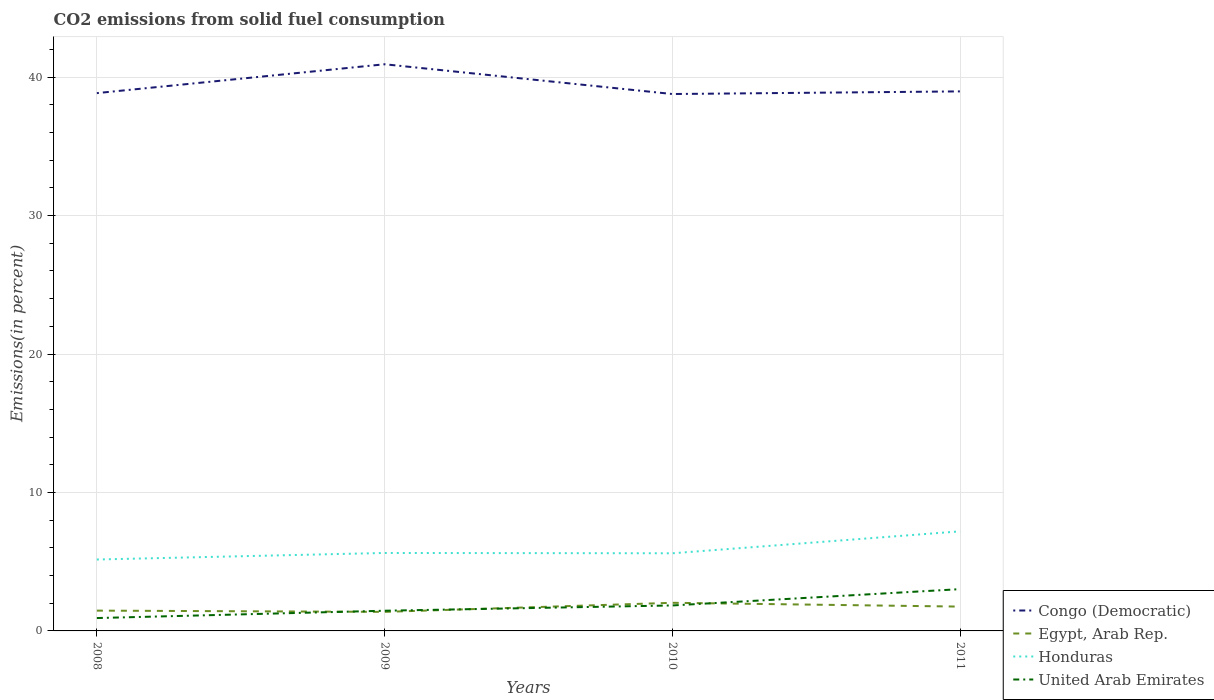How many different coloured lines are there?
Your response must be concise. 4. Does the line corresponding to United Arab Emirates intersect with the line corresponding to Honduras?
Provide a succinct answer. No. Is the number of lines equal to the number of legend labels?
Offer a very short reply. Yes. Across all years, what is the maximum total CO2 emitted in United Arab Emirates?
Ensure brevity in your answer.  0.93. What is the total total CO2 emitted in Egypt, Arab Rep. in the graph?
Provide a short and direct response. -0.66. What is the difference between the highest and the second highest total CO2 emitted in Honduras?
Offer a very short reply. 2.03. Is the total CO2 emitted in United Arab Emirates strictly greater than the total CO2 emitted in Honduras over the years?
Provide a short and direct response. Yes. How many lines are there?
Give a very brief answer. 4. How many years are there in the graph?
Your answer should be very brief. 4. What is the difference between two consecutive major ticks on the Y-axis?
Your answer should be compact. 10. Does the graph contain any zero values?
Your answer should be compact. No. Does the graph contain grids?
Give a very brief answer. Yes. Where does the legend appear in the graph?
Make the answer very short. Bottom right. How many legend labels are there?
Make the answer very short. 4. How are the legend labels stacked?
Provide a succinct answer. Vertical. What is the title of the graph?
Offer a terse response. CO2 emissions from solid fuel consumption. What is the label or title of the X-axis?
Offer a very short reply. Years. What is the label or title of the Y-axis?
Your response must be concise. Emissions(in percent). What is the Emissions(in percent) of Congo (Democratic) in 2008?
Give a very brief answer. 38.85. What is the Emissions(in percent) of Egypt, Arab Rep. in 2008?
Give a very brief answer. 1.47. What is the Emissions(in percent) of Honduras in 2008?
Ensure brevity in your answer.  5.16. What is the Emissions(in percent) of United Arab Emirates in 2008?
Offer a very short reply. 0.93. What is the Emissions(in percent) of Congo (Democratic) in 2009?
Offer a terse response. 40.93. What is the Emissions(in percent) of Egypt, Arab Rep. in 2009?
Keep it short and to the point. 1.38. What is the Emissions(in percent) of Honduras in 2009?
Your answer should be compact. 5.63. What is the Emissions(in percent) of United Arab Emirates in 2009?
Keep it short and to the point. 1.46. What is the Emissions(in percent) in Congo (Democratic) in 2010?
Offer a very short reply. 38.78. What is the Emissions(in percent) of Egypt, Arab Rep. in 2010?
Your response must be concise. 2.03. What is the Emissions(in percent) in Honduras in 2010?
Your answer should be compact. 5.61. What is the Emissions(in percent) of United Arab Emirates in 2010?
Give a very brief answer. 1.84. What is the Emissions(in percent) in Congo (Democratic) in 2011?
Make the answer very short. 38.97. What is the Emissions(in percent) of Egypt, Arab Rep. in 2011?
Provide a short and direct response. 1.76. What is the Emissions(in percent) in Honduras in 2011?
Offer a very short reply. 7.19. What is the Emissions(in percent) of United Arab Emirates in 2011?
Offer a terse response. 3.02. Across all years, what is the maximum Emissions(in percent) in Congo (Democratic)?
Make the answer very short. 40.93. Across all years, what is the maximum Emissions(in percent) of Egypt, Arab Rep.?
Make the answer very short. 2.03. Across all years, what is the maximum Emissions(in percent) of Honduras?
Provide a short and direct response. 7.19. Across all years, what is the maximum Emissions(in percent) in United Arab Emirates?
Offer a terse response. 3.02. Across all years, what is the minimum Emissions(in percent) in Congo (Democratic)?
Your answer should be very brief. 38.78. Across all years, what is the minimum Emissions(in percent) in Egypt, Arab Rep.?
Your response must be concise. 1.38. Across all years, what is the minimum Emissions(in percent) of Honduras?
Your response must be concise. 5.16. Across all years, what is the minimum Emissions(in percent) in United Arab Emirates?
Give a very brief answer. 0.93. What is the total Emissions(in percent) in Congo (Democratic) in the graph?
Offer a very short reply. 157.53. What is the total Emissions(in percent) of Egypt, Arab Rep. in the graph?
Make the answer very short. 6.63. What is the total Emissions(in percent) of Honduras in the graph?
Your answer should be compact. 23.59. What is the total Emissions(in percent) in United Arab Emirates in the graph?
Offer a terse response. 7.25. What is the difference between the Emissions(in percent) of Congo (Democratic) in 2008 and that in 2009?
Provide a short and direct response. -2.08. What is the difference between the Emissions(in percent) of Egypt, Arab Rep. in 2008 and that in 2009?
Your response must be concise. 0.09. What is the difference between the Emissions(in percent) of Honduras in 2008 and that in 2009?
Make the answer very short. -0.47. What is the difference between the Emissions(in percent) of United Arab Emirates in 2008 and that in 2009?
Provide a short and direct response. -0.53. What is the difference between the Emissions(in percent) of Congo (Democratic) in 2008 and that in 2010?
Your response must be concise. 0.07. What is the difference between the Emissions(in percent) in Egypt, Arab Rep. in 2008 and that in 2010?
Make the answer very short. -0.57. What is the difference between the Emissions(in percent) in Honduras in 2008 and that in 2010?
Provide a succinct answer. -0.45. What is the difference between the Emissions(in percent) of United Arab Emirates in 2008 and that in 2010?
Offer a terse response. -0.91. What is the difference between the Emissions(in percent) of Congo (Democratic) in 2008 and that in 2011?
Make the answer very short. -0.12. What is the difference between the Emissions(in percent) in Egypt, Arab Rep. in 2008 and that in 2011?
Make the answer very short. -0.29. What is the difference between the Emissions(in percent) of Honduras in 2008 and that in 2011?
Your response must be concise. -2.03. What is the difference between the Emissions(in percent) of United Arab Emirates in 2008 and that in 2011?
Make the answer very short. -2.09. What is the difference between the Emissions(in percent) in Congo (Democratic) in 2009 and that in 2010?
Offer a very short reply. 2.15. What is the difference between the Emissions(in percent) in Egypt, Arab Rep. in 2009 and that in 2010?
Offer a very short reply. -0.66. What is the difference between the Emissions(in percent) in Honduras in 2009 and that in 2010?
Your answer should be very brief. 0.02. What is the difference between the Emissions(in percent) in United Arab Emirates in 2009 and that in 2010?
Offer a very short reply. -0.38. What is the difference between the Emissions(in percent) of Congo (Democratic) in 2009 and that in 2011?
Ensure brevity in your answer.  1.96. What is the difference between the Emissions(in percent) in Egypt, Arab Rep. in 2009 and that in 2011?
Offer a terse response. -0.38. What is the difference between the Emissions(in percent) in Honduras in 2009 and that in 2011?
Offer a terse response. -1.56. What is the difference between the Emissions(in percent) of United Arab Emirates in 2009 and that in 2011?
Offer a very short reply. -1.56. What is the difference between the Emissions(in percent) of Congo (Democratic) in 2010 and that in 2011?
Your answer should be very brief. -0.19. What is the difference between the Emissions(in percent) in Egypt, Arab Rep. in 2010 and that in 2011?
Provide a succinct answer. 0.27. What is the difference between the Emissions(in percent) in Honduras in 2010 and that in 2011?
Ensure brevity in your answer.  -1.58. What is the difference between the Emissions(in percent) in United Arab Emirates in 2010 and that in 2011?
Give a very brief answer. -1.18. What is the difference between the Emissions(in percent) in Congo (Democratic) in 2008 and the Emissions(in percent) in Egypt, Arab Rep. in 2009?
Ensure brevity in your answer.  37.47. What is the difference between the Emissions(in percent) in Congo (Democratic) in 2008 and the Emissions(in percent) in Honduras in 2009?
Your answer should be compact. 33.22. What is the difference between the Emissions(in percent) in Congo (Democratic) in 2008 and the Emissions(in percent) in United Arab Emirates in 2009?
Keep it short and to the point. 37.39. What is the difference between the Emissions(in percent) in Egypt, Arab Rep. in 2008 and the Emissions(in percent) in Honduras in 2009?
Your answer should be compact. -4.16. What is the difference between the Emissions(in percent) of Egypt, Arab Rep. in 2008 and the Emissions(in percent) of United Arab Emirates in 2009?
Your response must be concise. 0.01. What is the difference between the Emissions(in percent) in Honduras in 2008 and the Emissions(in percent) in United Arab Emirates in 2009?
Your answer should be compact. 3.7. What is the difference between the Emissions(in percent) of Congo (Democratic) in 2008 and the Emissions(in percent) of Egypt, Arab Rep. in 2010?
Offer a very short reply. 36.82. What is the difference between the Emissions(in percent) of Congo (Democratic) in 2008 and the Emissions(in percent) of Honduras in 2010?
Offer a terse response. 33.24. What is the difference between the Emissions(in percent) in Congo (Democratic) in 2008 and the Emissions(in percent) in United Arab Emirates in 2010?
Make the answer very short. 37.01. What is the difference between the Emissions(in percent) in Egypt, Arab Rep. in 2008 and the Emissions(in percent) in Honduras in 2010?
Make the answer very short. -4.14. What is the difference between the Emissions(in percent) in Egypt, Arab Rep. in 2008 and the Emissions(in percent) in United Arab Emirates in 2010?
Provide a succinct answer. -0.37. What is the difference between the Emissions(in percent) of Honduras in 2008 and the Emissions(in percent) of United Arab Emirates in 2010?
Your answer should be compact. 3.32. What is the difference between the Emissions(in percent) of Congo (Democratic) in 2008 and the Emissions(in percent) of Egypt, Arab Rep. in 2011?
Provide a short and direct response. 37.09. What is the difference between the Emissions(in percent) in Congo (Democratic) in 2008 and the Emissions(in percent) in Honduras in 2011?
Provide a short and direct response. 31.66. What is the difference between the Emissions(in percent) of Congo (Democratic) in 2008 and the Emissions(in percent) of United Arab Emirates in 2011?
Provide a short and direct response. 35.83. What is the difference between the Emissions(in percent) of Egypt, Arab Rep. in 2008 and the Emissions(in percent) of Honduras in 2011?
Offer a very short reply. -5.73. What is the difference between the Emissions(in percent) of Egypt, Arab Rep. in 2008 and the Emissions(in percent) of United Arab Emirates in 2011?
Your answer should be very brief. -1.55. What is the difference between the Emissions(in percent) in Honduras in 2008 and the Emissions(in percent) in United Arab Emirates in 2011?
Provide a short and direct response. 2.14. What is the difference between the Emissions(in percent) in Congo (Democratic) in 2009 and the Emissions(in percent) in Egypt, Arab Rep. in 2010?
Offer a terse response. 38.9. What is the difference between the Emissions(in percent) of Congo (Democratic) in 2009 and the Emissions(in percent) of Honduras in 2010?
Your answer should be compact. 35.32. What is the difference between the Emissions(in percent) in Congo (Democratic) in 2009 and the Emissions(in percent) in United Arab Emirates in 2010?
Offer a very short reply. 39.09. What is the difference between the Emissions(in percent) of Egypt, Arab Rep. in 2009 and the Emissions(in percent) of Honduras in 2010?
Your response must be concise. -4.23. What is the difference between the Emissions(in percent) in Egypt, Arab Rep. in 2009 and the Emissions(in percent) in United Arab Emirates in 2010?
Your answer should be compact. -0.46. What is the difference between the Emissions(in percent) in Honduras in 2009 and the Emissions(in percent) in United Arab Emirates in 2010?
Provide a short and direct response. 3.79. What is the difference between the Emissions(in percent) in Congo (Democratic) in 2009 and the Emissions(in percent) in Egypt, Arab Rep. in 2011?
Offer a terse response. 39.17. What is the difference between the Emissions(in percent) of Congo (Democratic) in 2009 and the Emissions(in percent) of Honduras in 2011?
Your answer should be very brief. 33.74. What is the difference between the Emissions(in percent) of Congo (Democratic) in 2009 and the Emissions(in percent) of United Arab Emirates in 2011?
Your response must be concise. 37.91. What is the difference between the Emissions(in percent) of Egypt, Arab Rep. in 2009 and the Emissions(in percent) of Honduras in 2011?
Your response must be concise. -5.82. What is the difference between the Emissions(in percent) of Egypt, Arab Rep. in 2009 and the Emissions(in percent) of United Arab Emirates in 2011?
Your answer should be very brief. -1.64. What is the difference between the Emissions(in percent) of Honduras in 2009 and the Emissions(in percent) of United Arab Emirates in 2011?
Ensure brevity in your answer.  2.61. What is the difference between the Emissions(in percent) of Congo (Democratic) in 2010 and the Emissions(in percent) of Egypt, Arab Rep. in 2011?
Keep it short and to the point. 37.03. What is the difference between the Emissions(in percent) in Congo (Democratic) in 2010 and the Emissions(in percent) in Honduras in 2011?
Your answer should be compact. 31.59. What is the difference between the Emissions(in percent) in Congo (Democratic) in 2010 and the Emissions(in percent) in United Arab Emirates in 2011?
Provide a succinct answer. 35.76. What is the difference between the Emissions(in percent) of Egypt, Arab Rep. in 2010 and the Emissions(in percent) of Honduras in 2011?
Make the answer very short. -5.16. What is the difference between the Emissions(in percent) in Egypt, Arab Rep. in 2010 and the Emissions(in percent) in United Arab Emirates in 2011?
Ensure brevity in your answer.  -0.99. What is the difference between the Emissions(in percent) in Honduras in 2010 and the Emissions(in percent) in United Arab Emirates in 2011?
Offer a very short reply. 2.59. What is the average Emissions(in percent) in Congo (Democratic) per year?
Offer a terse response. 39.38. What is the average Emissions(in percent) in Egypt, Arab Rep. per year?
Your answer should be very brief. 1.66. What is the average Emissions(in percent) in Honduras per year?
Make the answer very short. 5.9. What is the average Emissions(in percent) of United Arab Emirates per year?
Provide a short and direct response. 1.81. In the year 2008, what is the difference between the Emissions(in percent) of Congo (Democratic) and Emissions(in percent) of Egypt, Arab Rep.?
Keep it short and to the point. 37.38. In the year 2008, what is the difference between the Emissions(in percent) in Congo (Democratic) and Emissions(in percent) in Honduras?
Your response must be concise. 33.69. In the year 2008, what is the difference between the Emissions(in percent) of Congo (Democratic) and Emissions(in percent) of United Arab Emirates?
Keep it short and to the point. 37.92. In the year 2008, what is the difference between the Emissions(in percent) in Egypt, Arab Rep. and Emissions(in percent) in Honduras?
Your answer should be compact. -3.69. In the year 2008, what is the difference between the Emissions(in percent) of Egypt, Arab Rep. and Emissions(in percent) of United Arab Emirates?
Ensure brevity in your answer.  0.54. In the year 2008, what is the difference between the Emissions(in percent) in Honduras and Emissions(in percent) in United Arab Emirates?
Provide a succinct answer. 4.23. In the year 2009, what is the difference between the Emissions(in percent) in Congo (Democratic) and Emissions(in percent) in Egypt, Arab Rep.?
Ensure brevity in your answer.  39.56. In the year 2009, what is the difference between the Emissions(in percent) in Congo (Democratic) and Emissions(in percent) in Honduras?
Provide a succinct answer. 35.3. In the year 2009, what is the difference between the Emissions(in percent) of Congo (Democratic) and Emissions(in percent) of United Arab Emirates?
Ensure brevity in your answer.  39.47. In the year 2009, what is the difference between the Emissions(in percent) in Egypt, Arab Rep. and Emissions(in percent) in Honduras?
Offer a very short reply. -4.26. In the year 2009, what is the difference between the Emissions(in percent) in Egypt, Arab Rep. and Emissions(in percent) in United Arab Emirates?
Provide a succinct answer. -0.08. In the year 2009, what is the difference between the Emissions(in percent) of Honduras and Emissions(in percent) of United Arab Emirates?
Give a very brief answer. 4.17. In the year 2010, what is the difference between the Emissions(in percent) of Congo (Democratic) and Emissions(in percent) of Egypt, Arab Rep.?
Ensure brevity in your answer.  36.75. In the year 2010, what is the difference between the Emissions(in percent) in Congo (Democratic) and Emissions(in percent) in Honduras?
Make the answer very short. 33.17. In the year 2010, what is the difference between the Emissions(in percent) in Congo (Democratic) and Emissions(in percent) in United Arab Emirates?
Offer a terse response. 36.94. In the year 2010, what is the difference between the Emissions(in percent) in Egypt, Arab Rep. and Emissions(in percent) in Honduras?
Your answer should be very brief. -3.58. In the year 2010, what is the difference between the Emissions(in percent) of Egypt, Arab Rep. and Emissions(in percent) of United Arab Emirates?
Offer a terse response. 0.19. In the year 2010, what is the difference between the Emissions(in percent) of Honduras and Emissions(in percent) of United Arab Emirates?
Offer a terse response. 3.77. In the year 2011, what is the difference between the Emissions(in percent) in Congo (Democratic) and Emissions(in percent) in Egypt, Arab Rep.?
Your answer should be very brief. 37.22. In the year 2011, what is the difference between the Emissions(in percent) of Congo (Democratic) and Emissions(in percent) of Honduras?
Your answer should be compact. 31.78. In the year 2011, what is the difference between the Emissions(in percent) of Congo (Democratic) and Emissions(in percent) of United Arab Emirates?
Provide a succinct answer. 35.95. In the year 2011, what is the difference between the Emissions(in percent) in Egypt, Arab Rep. and Emissions(in percent) in Honduras?
Your response must be concise. -5.44. In the year 2011, what is the difference between the Emissions(in percent) in Egypt, Arab Rep. and Emissions(in percent) in United Arab Emirates?
Provide a short and direct response. -1.26. In the year 2011, what is the difference between the Emissions(in percent) in Honduras and Emissions(in percent) in United Arab Emirates?
Offer a very short reply. 4.17. What is the ratio of the Emissions(in percent) of Congo (Democratic) in 2008 to that in 2009?
Your answer should be compact. 0.95. What is the ratio of the Emissions(in percent) in Egypt, Arab Rep. in 2008 to that in 2009?
Provide a short and direct response. 1.07. What is the ratio of the Emissions(in percent) in Honduras in 2008 to that in 2009?
Your response must be concise. 0.92. What is the ratio of the Emissions(in percent) of United Arab Emirates in 2008 to that in 2009?
Provide a succinct answer. 0.64. What is the ratio of the Emissions(in percent) of Congo (Democratic) in 2008 to that in 2010?
Ensure brevity in your answer.  1. What is the ratio of the Emissions(in percent) in Egypt, Arab Rep. in 2008 to that in 2010?
Provide a short and direct response. 0.72. What is the ratio of the Emissions(in percent) in Honduras in 2008 to that in 2010?
Ensure brevity in your answer.  0.92. What is the ratio of the Emissions(in percent) in United Arab Emirates in 2008 to that in 2010?
Ensure brevity in your answer.  0.51. What is the ratio of the Emissions(in percent) of Congo (Democratic) in 2008 to that in 2011?
Ensure brevity in your answer.  1. What is the ratio of the Emissions(in percent) in Egypt, Arab Rep. in 2008 to that in 2011?
Your answer should be very brief. 0.83. What is the ratio of the Emissions(in percent) of Honduras in 2008 to that in 2011?
Provide a succinct answer. 0.72. What is the ratio of the Emissions(in percent) in United Arab Emirates in 2008 to that in 2011?
Offer a very short reply. 0.31. What is the ratio of the Emissions(in percent) in Congo (Democratic) in 2009 to that in 2010?
Provide a short and direct response. 1.06. What is the ratio of the Emissions(in percent) of Egypt, Arab Rep. in 2009 to that in 2010?
Your response must be concise. 0.68. What is the ratio of the Emissions(in percent) of United Arab Emirates in 2009 to that in 2010?
Ensure brevity in your answer.  0.79. What is the ratio of the Emissions(in percent) in Congo (Democratic) in 2009 to that in 2011?
Your response must be concise. 1.05. What is the ratio of the Emissions(in percent) of Egypt, Arab Rep. in 2009 to that in 2011?
Provide a succinct answer. 0.78. What is the ratio of the Emissions(in percent) in Honduras in 2009 to that in 2011?
Ensure brevity in your answer.  0.78. What is the ratio of the Emissions(in percent) in United Arab Emirates in 2009 to that in 2011?
Give a very brief answer. 0.48. What is the ratio of the Emissions(in percent) of Congo (Democratic) in 2010 to that in 2011?
Offer a very short reply. 1. What is the ratio of the Emissions(in percent) in Egypt, Arab Rep. in 2010 to that in 2011?
Your answer should be very brief. 1.16. What is the ratio of the Emissions(in percent) in Honduras in 2010 to that in 2011?
Your answer should be very brief. 0.78. What is the ratio of the Emissions(in percent) of United Arab Emirates in 2010 to that in 2011?
Your answer should be very brief. 0.61. What is the difference between the highest and the second highest Emissions(in percent) of Congo (Democratic)?
Ensure brevity in your answer.  1.96. What is the difference between the highest and the second highest Emissions(in percent) of Egypt, Arab Rep.?
Your answer should be compact. 0.27. What is the difference between the highest and the second highest Emissions(in percent) in Honduras?
Your answer should be compact. 1.56. What is the difference between the highest and the second highest Emissions(in percent) in United Arab Emirates?
Give a very brief answer. 1.18. What is the difference between the highest and the lowest Emissions(in percent) in Congo (Democratic)?
Offer a terse response. 2.15. What is the difference between the highest and the lowest Emissions(in percent) of Egypt, Arab Rep.?
Offer a terse response. 0.66. What is the difference between the highest and the lowest Emissions(in percent) in Honduras?
Offer a very short reply. 2.03. What is the difference between the highest and the lowest Emissions(in percent) of United Arab Emirates?
Offer a very short reply. 2.09. 